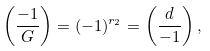<formula> <loc_0><loc_0><loc_500><loc_500>\left ( \frac { - 1 } { G } \right ) = ( - 1 ) ^ { r _ { 2 } } = \left ( \frac { d } { - 1 } \right ) ,</formula> 